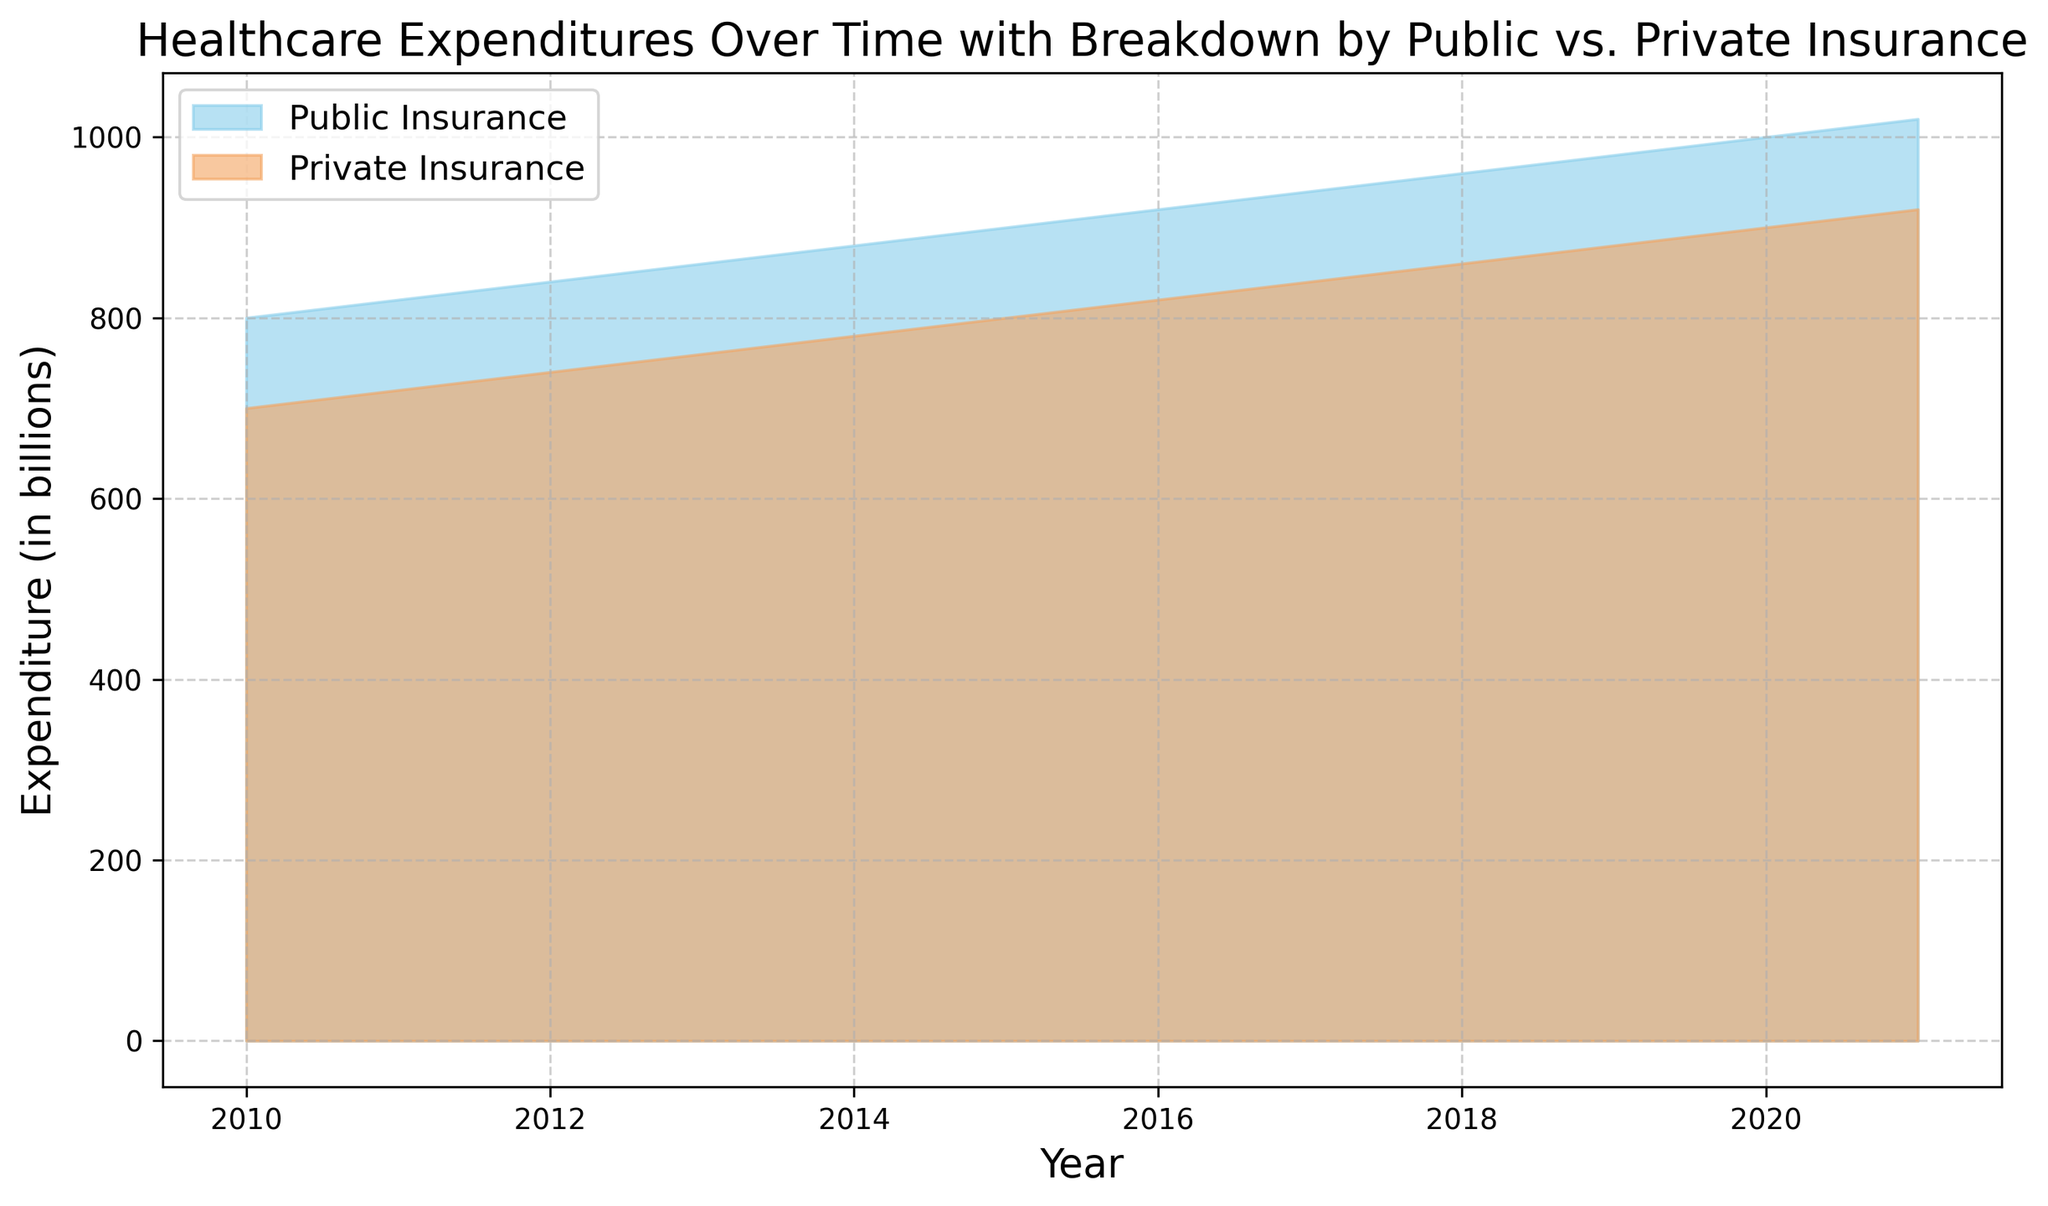Which type of insurance had higher expenditures in 2020? Look at the heights of the areas for both public and private insurance in 2020. The public insurance expenditure is higher compared to private insurance.
Answer: Public insurance In what year did public insurance expenditure surpass 900 billion? Examine the plot and identify the year when the public insurance area first crosses the 900 billion mark. This occurs in 2015.
Answer: 2015 What is the difference in expenditures between public and private insurance in 2021? In 2021, find the heights of the public and private insurance areas, which are 1020 billion and 920 billion respectively. The difference is 1020 - 920 = 100 billion.
Answer: 100 billion Between which years did public insurance expenditure show the fastest growth? Compare the slopes of the public insurance area between consecutive years. The steeper the slope, the faster the growth. The growth appears most rapid between 2019 and 2020.
Answer: 2019-2020 What is the combined expenditure from both public and private insurance in 2018? Add the expenditures of public (960 billion) and private (860 billion) insurance in 2018. The sum is 960 + 860 = 1820 billion.
Answer: 1820 billion How does the growth trend of private insurance expenditures compare to that of public insurance expenditures from 2010 to 2021? Examine the slope of the growth for both public and private insurance areas. Both show a linear increase, but public insurance grows at a consistently higher rate compared to private insurance.
Answer: Public insurance grows faster Which year had the smallest gap between public and private insurance expenditures? Calculate the difference between expenditure areas for each year and identify the smallest gap. The smallest difference occurs in 2010, where public insurance is 800 billion and private is 700 billion, with a gap of 100 billion.
Answer: 2010 What is the average annual increase in public insurance expenditures from 2010 to 2021? Find the increase in public insurance expenditures from 2010 (800 billion) to 2021 (1020 billion). The total increase is 1020 - 800 = 220 billion. Divide this by 11 (the number of years) to get the average annual increase, 220/11 = 20 billion.
Answer: 20 billion Does private insurance ever exceed public insurance in terms of expenditures over the years shown? Look at the plot to see if the area for private insurance ever goes above that of public insurance between 2010 and 2021. It does not.
Answer: No By how much did private insurance expenditures increase from 2013 to 2016? Find the private insurance expenditures for 2013 (760 billion) and 2016 (820 billion). The increase is 820 - 760 = 60 billion.
Answer: 60 billion 